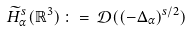<formula> <loc_0><loc_0><loc_500><loc_500>\widetilde { H } ^ { s } _ { \alpha } ( \mathbb { R } ^ { 3 } ) \, \colon = \, \mathcal { D } ( ( - \Delta _ { \alpha } ) ^ { s / 2 } )</formula> 